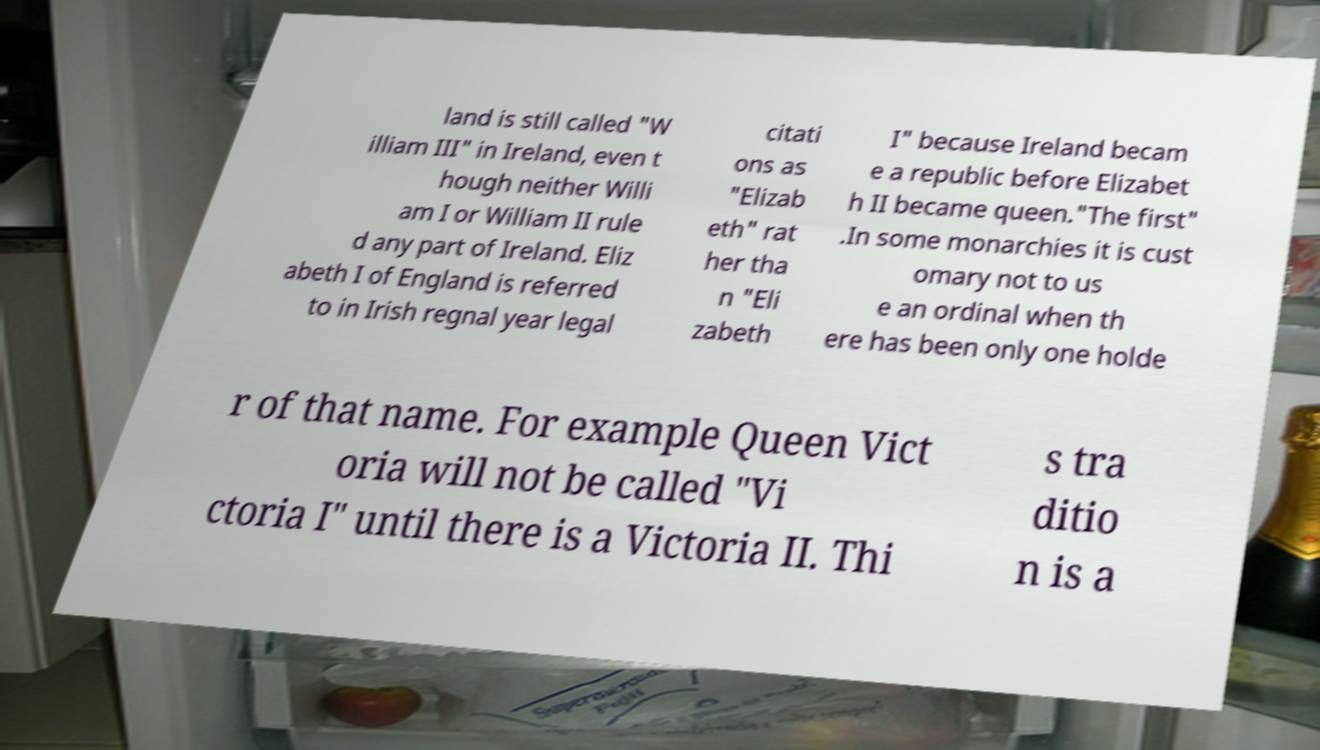Could you extract and type out the text from this image? land is still called "W illiam III" in Ireland, even t hough neither Willi am I or William II rule d any part of Ireland. Eliz abeth I of England is referred to in Irish regnal year legal citati ons as "Elizab eth" rat her tha n "Eli zabeth I" because Ireland becam e a republic before Elizabet h II became queen."The first" .In some monarchies it is cust omary not to us e an ordinal when th ere has been only one holde r of that name. For example Queen Vict oria will not be called "Vi ctoria I" until there is a Victoria II. Thi s tra ditio n is a 